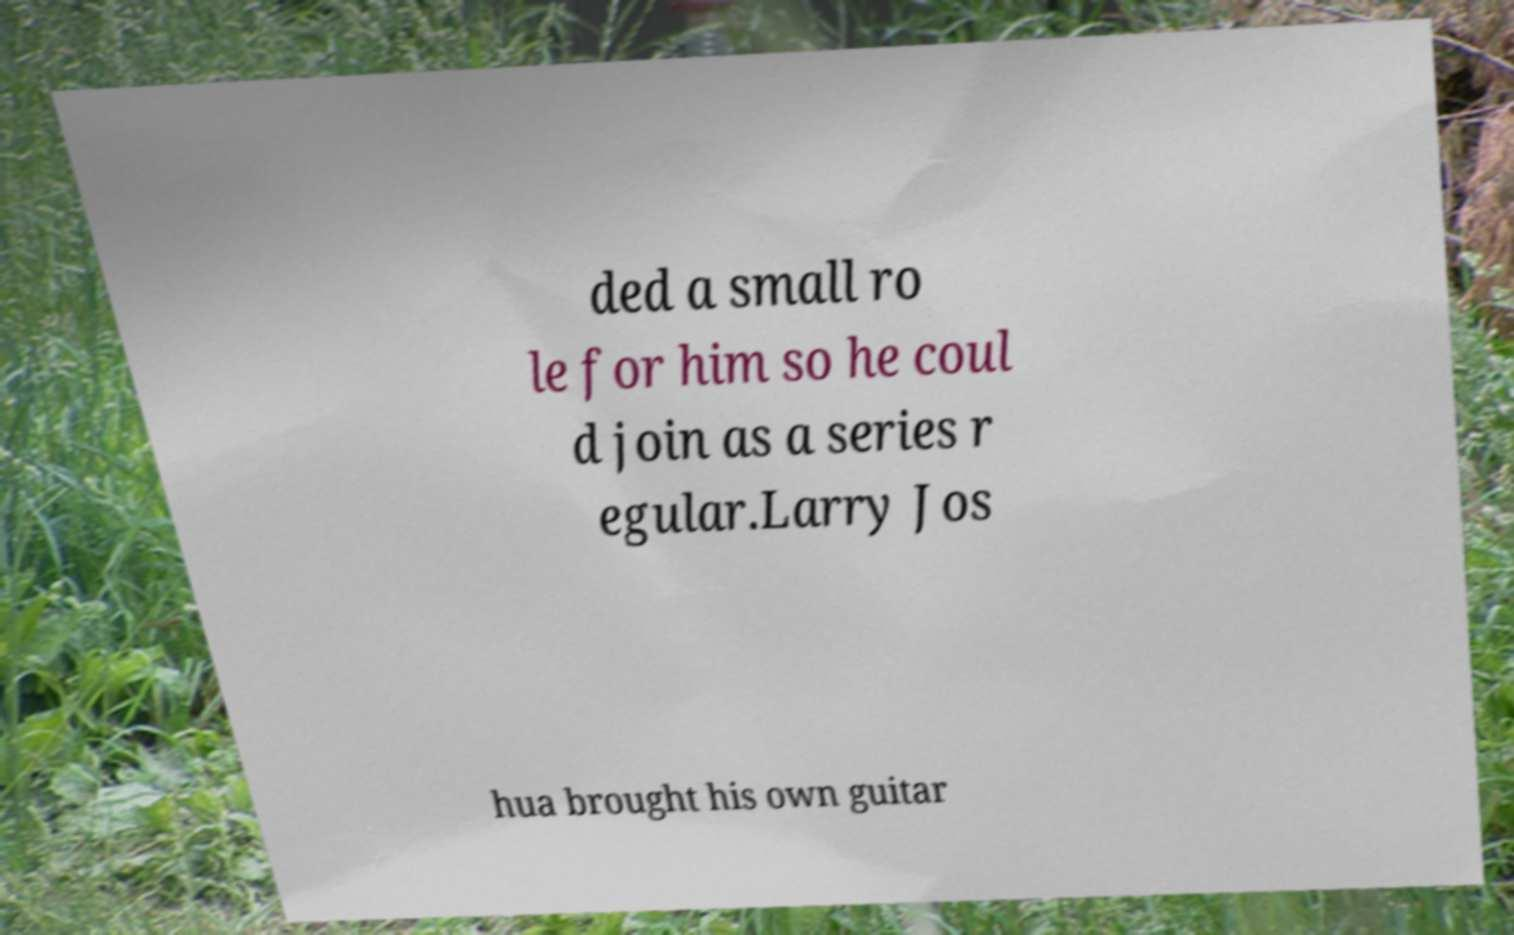There's text embedded in this image that I need extracted. Can you transcribe it verbatim? ded a small ro le for him so he coul d join as a series r egular.Larry Jos hua brought his own guitar 